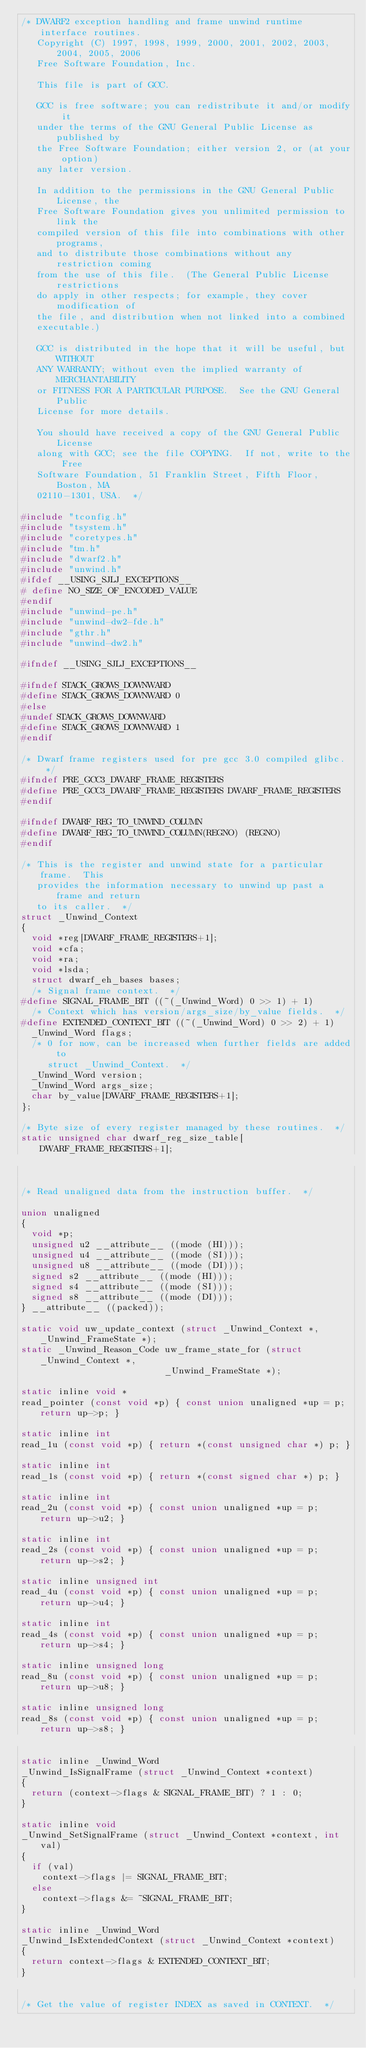<code> <loc_0><loc_0><loc_500><loc_500><_C_>/* DWARF2 exception handling and frame unwind runtime interface routines.
   Copyright (C) 1997, 1998, 1999, 2000, 2001, 2002, 2003, 2004, 2005, 2006
   Free Software Foundation, Inc.

   This file is part of GCC.

   GCC is free software; you can redistribute it and/or modify it
   under the terms of the GNU General Public License as published by
   the Free Software Foundation; either version 2, or (at your option)
   any later version.

   In addition to the permissions in the GNU General Public License, the
   Free Software Foundation gives you unlimited permission to link the
   compiled version of this file into combinations with other programs,
   and to distribute those combinations without any restriction coming
   from the use of this file.  (The General Public License restrictions
   do apply in other respects; for example, they cover modification of
   the file, and distribution when not linked into a combined
   executable.)

   GCC is distributed in the hope that it will be useful, but WITHOUT
   ANY WARRANTY; without even the implied warranty of MERCHANTABILITY
   or FITNESS FOR A PARTICULAR PURPOSE.  See the GNU General Public
   License for more details.

   You should have received a copy of the GNU General Public License
   along with GCC; see the file COPYING.  If not, write to the Free
   Software Foundation, 51 Franklin Street, Fifth Floor, Boston, MA
   02110-1301, USA.  */

#include "tconfig.h"
#include "tsystem.h"
#include "coretypes.h"
#include "tm.h"
#include "dwarf2.h"
#include "unwind.h"
#ifdef __USING_SJLJ_EXCEPTIONS__
# define NO_SIZE_OF_ENCODED_VALUE
#endif
#include "unwind-pe.h"
#include "unwind-dw2-fde.h"
#include "gthr.h"
#include "unwind-dw2.h"

#ifndef __USING_SJLJ_EXCEPTIONS__

#ifndef STACK_GROWS_DOWNWARD
#define STACK_GROWS_DOWNWARD 0
#else
#undef STACK_GROWS_DOWNWARD
#define STACK_GROWS_DOWNWARD 1
#endif

/* Dwarf frame registers used for pre gcc 3.0 compiled glibc.  */
#ifndef PRE_GCC3_DWARF_FRAME_REGISTERS
#define PRE_GCC3_DWARF_FRAME_REGISTERS DWARF_FRAME_REGISTERS
#endif

#ifndef DWARF_REG_TO_UNWIND_COLUMN
#define DWARF_REG_TO_UNWIND_COLUMN(REGNO) (REGNO)
#endif

/* This is the register and unwind state for a particular frame.  This
   provides the information necessary to unwind up past a frame and return
   to its caller.  */
struct _Unwind_Context
{
  void *reg[DWARF_FRAME_REGISTERS+1];
  void *cfa;
  void *ra;
  void *lsda;
  struct dwarf_eh_bases bases;
  /* Signal frame context.  */
#define SIGNAL_FRAME_BIT ((~(_Unwind_Word) 0 >> 1) + 1)
  /* Context which has version/args_size/by_value fields.  */
#define EXTENDED_CONTEXT_BIT ((~(_Unwind_Word) 0 >> 2) + 1)
  _Unwind_Word flags;
  /* 0 for now, can be increased when further fields are added to
     struct _Unwind_Context.  */
  _Unwind_Word version;
  _Unwind_Word args_size;
  char by_value[DWARF_FRAME_REGISTERS+1];
};

/* Byte size of every register managed by these routines.  */
static unsigned char dwarf_reg_size_table[DWARF_FRAME_REGISTERS+1];


/* Read unaligned data from the instruction buffer.  */

union unaligned
{
  void *p;
  unsigned u2 __attribute__ ((mode (HI)));
  unsigned u4 __attribute__ ((mode (SI)));
  unsigned u8 __attribute__ ((mode (DI)));
  signed s2 __attribute__ ((mode (HI)));
  signed s4 __attribute__ ((mode (SI)));
  signed s8 __attribute__ ((mode (DI)));
} __attribute__ ((packed));

static void uw_update_context (struct _Unwind_Context *, _Unwind_FrameState *);
static _Unwind_Reason_Code uw_frame_state_for (struct _Unwind_Context *,
					       _Unwind_FrameState *);

static inline void *
read_pointer (const void *p) { const union unaligned *up = p; return up->p; }

static inline int
read_1u (const void *p) { return *(const unsigned char *) p; }

static inline int
read_1s (const void *p) { return *(const signed char *) p; }

static inline int
read_2u (const void *p) { const union unaligned *up = p; return up->u2; }

static inline int
read_2s (const void *p) { const union unaligned *up = p; return up->s2; }

static inline unsigned int
read_4u (const void *p) { const union unaligned *up = p; return up->u4; }

static inline int
read_4s (const void *p) { const union unaligned *up = p; return up->s4; }

static inline unsigned long
read_8u (const void *p) { const union unaligned *up = p; return up->u8; }

static inline unsigned long
read_8s (const void *p) { const union unaligned *up = p; return up->s8; }

static inline _Unwind_Word
_Unwind_IsSignalFrame (struct _Unwind_Context *context)
{
  return (context->flags & SIGNAL_FRAME_BIT) ? 1 : 0;
}

static inline void
_Unwind_SetSignalFrame (struct _Unwind_Context *context, int val)
{
  if (val)
    context->flags |= SIGNAL_FRAME_BIT;
  else
    context->flags &= ~SIGNAL_FRAME_BIT;
}

static inline _Unwind_Word
_Unwind_IsExtendedContext (struct _Unwind_Context *context)
{
  return context->flags & EXTENDED_CONTEXT_BIT;
}

/* Get the value of register INDEX as saved in CONTEXT.  */
</code> 